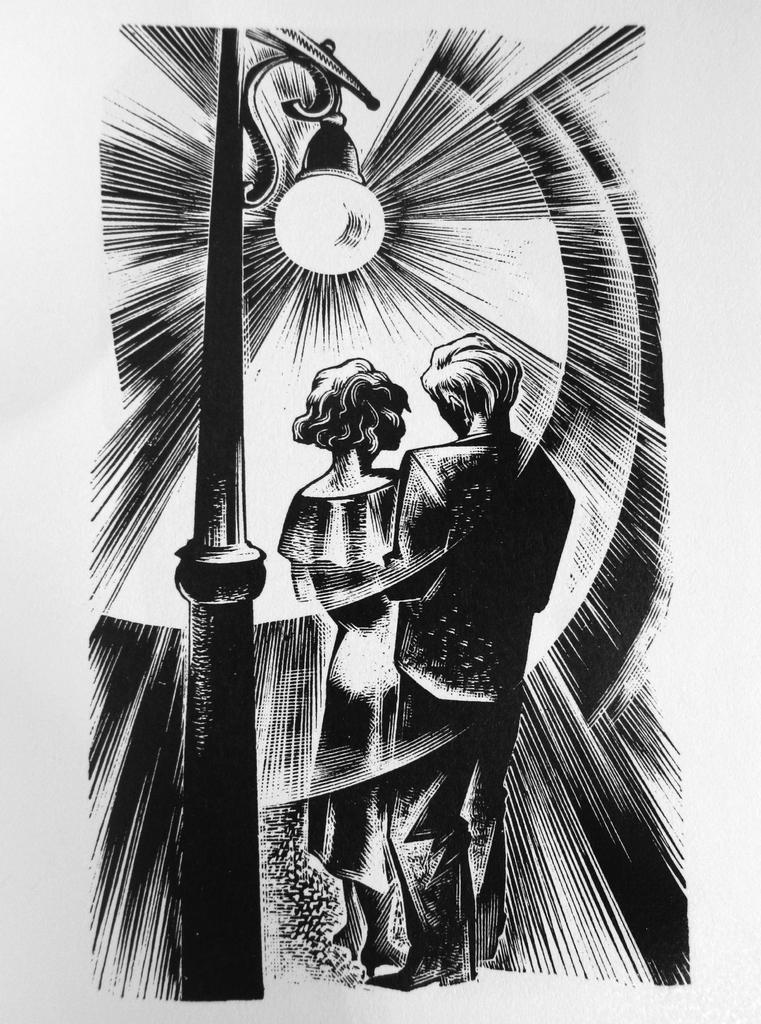What type of art is featured in the image? The image contains a black and white art. What is the subject matter of the art? The art depicts two persons. Can you describe any other elements in the image besides the art? Yes, there is a pole with a light in the image. What type of game are the two persons playing in the image? There is no game being played by the two persons in the image; they are depicted in an art piece. How many eyes does the woman in the image have? There is no woman present in the image, and therefore no such detail can be observed. 